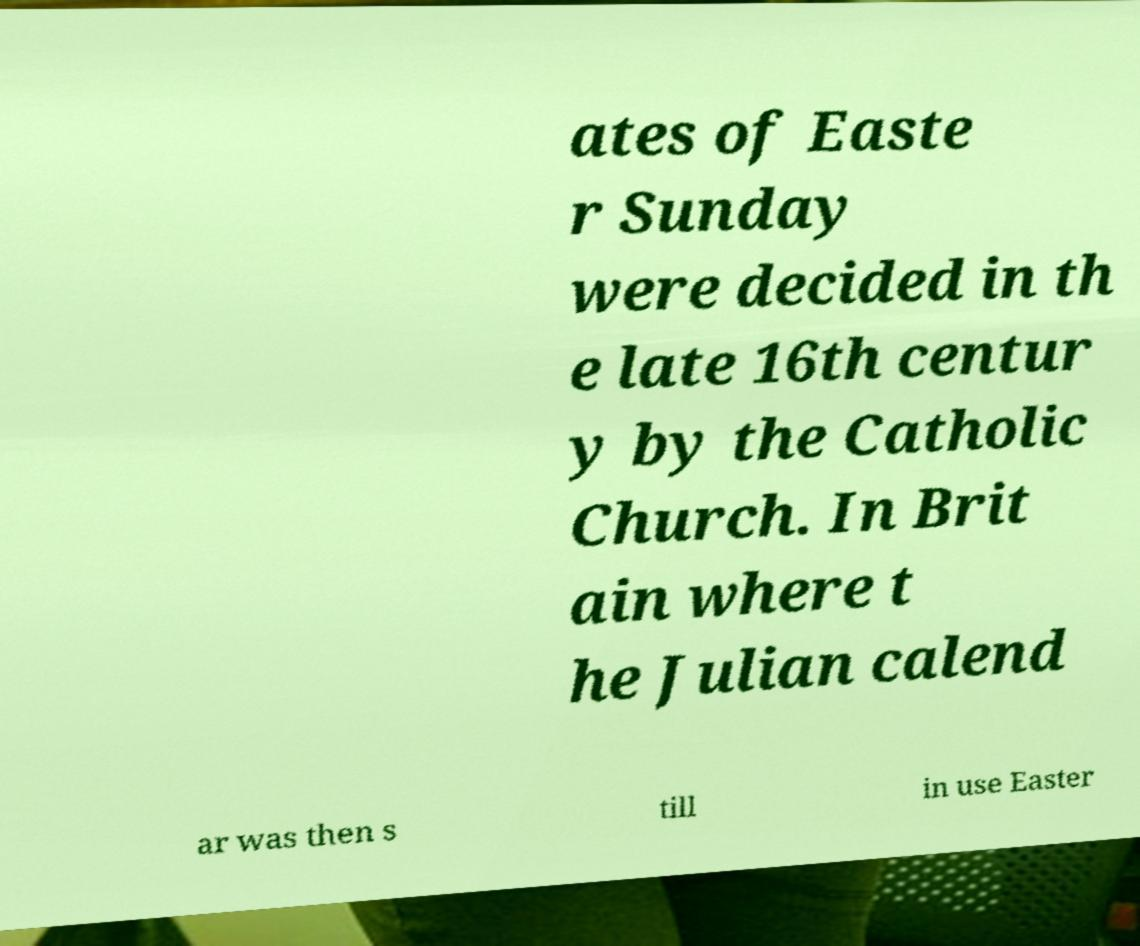Can you read and provide the text displayed in the image?This photo seems to have some interesting text. Can you extract and type it out for me? ates of Easte r Sunday were decided in th e late 16th centur y by the Catholic Church. In Brit ain where t he Julian calend ar was then s till in use Easter 